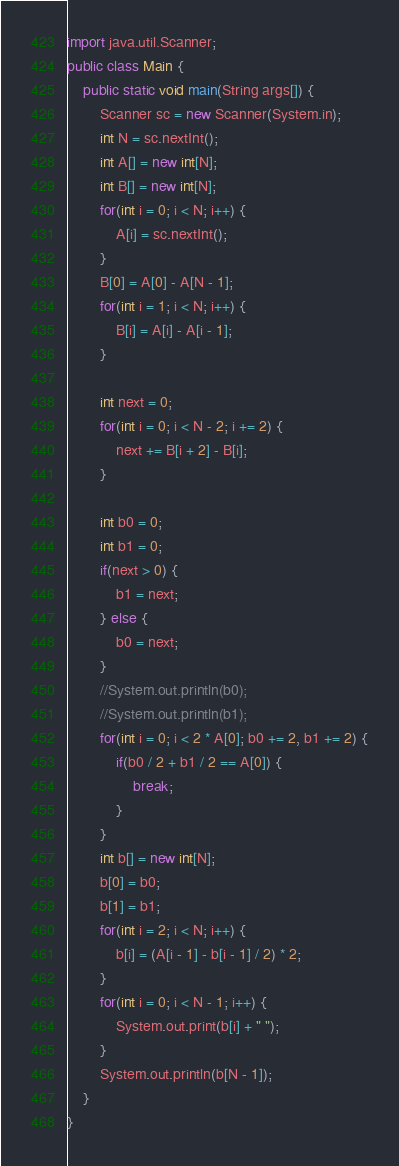Convert code to text. <code><loc_0><loc_0><loc_500><loc_500><_Java_>import java.util.Scanner;
public class Main {
	public static void main(String args[]) {
		Scanner sc = new Scanner(System.in);
		int N = sc.nextInt();
		int A[] = new int[N];
		int B[] = new int[N];
		for(int i = 0; i < N; i++) {
			A[i] = sc.nextInt();
		}
		B[0] = A[0] - A[N - 1];
		for(int i = 1; i < N; i++) {
			B[i] = A[i] - A[i - 1];
		}
		
		int next = 0;
		for(int i = 0; i < N - 2; i += 2) {
			next += B[i + 2] - B[i];
		}
		
		int b0 = 0;
		int b1 = 0;
		if(next > 0) {
			b1 = next;
		} else {
			b0 = next;
		}
		//System.out.println(b0);
		//System.out.println(b1);
		for(int i = 0; i < 2 * A[0]; b0 += 2, b1 += 2) {
			if(b0 / 2 + b1 / 2 == A[0]) {
				break;
			}
		}
		int b[] = new int[N];
		b[0] = b0;
		b[1] = b1;
		for(int i = 2; i < N; i++) {
			b[i] = (A[i - 1] - b[i - 1] / 2) * 2;
		}
		for(int i = 0; i < N - 1; i++) {
			System.out.print(b[i] + " ");
		}
		System.out.println(b[N - 1]);
	}
}
</code> 